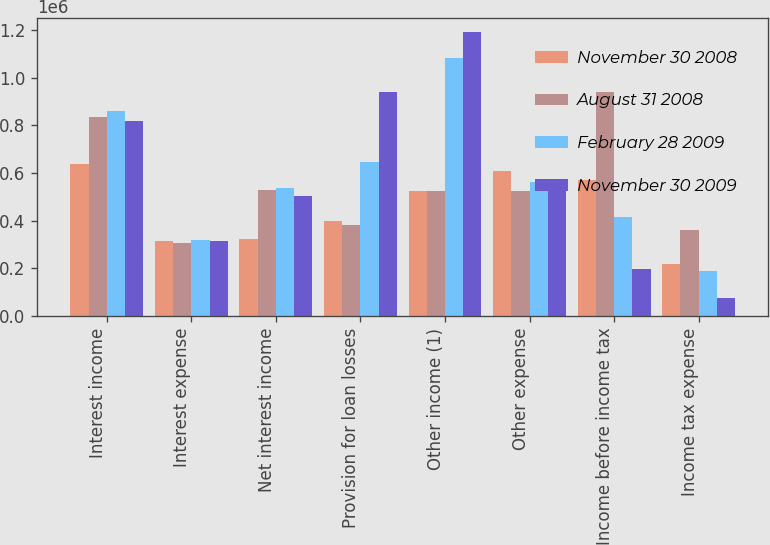Convert chart to OTSL. <chart><loc_0><loc_0><loc_500><loc_500><stacked_bar_chart><ecel><fcel>Interest income<fcel>Interest expense<fcel>Net interest income<fcel>Provision for loan losses<fcel>Other income (1)<fcel>Other expense<fcel>Income before income tax<fcel>Income tax expense<nl><fcel>November 30 2008<fcel>638086<fcel>314158<fcel>323928<fcel>399732<fcel>526327<fcel>607499<fcel>570256<fcel>217719<nl><fcel>August 31 2008<fcel>833217<fcel>304401<fcel>528816<fcel>380999<fcel>526327<fcel>523838<fcel>939939<fcel>362485<nl><fcel>February 28 2009<fcel>857984<fcel>320005<fcel>537979<fcel>643861<fcel>1.08112e+06<fcel>560628<fcel>414610<fcel>188810<nl><fcel>November 30 2009<fcel>815793<fcel>312720<fcel>503073<fcel>937813<fcel>1.18996e+06<fcel>559123<fcel>196093<fcel>75699<nl></chart> 